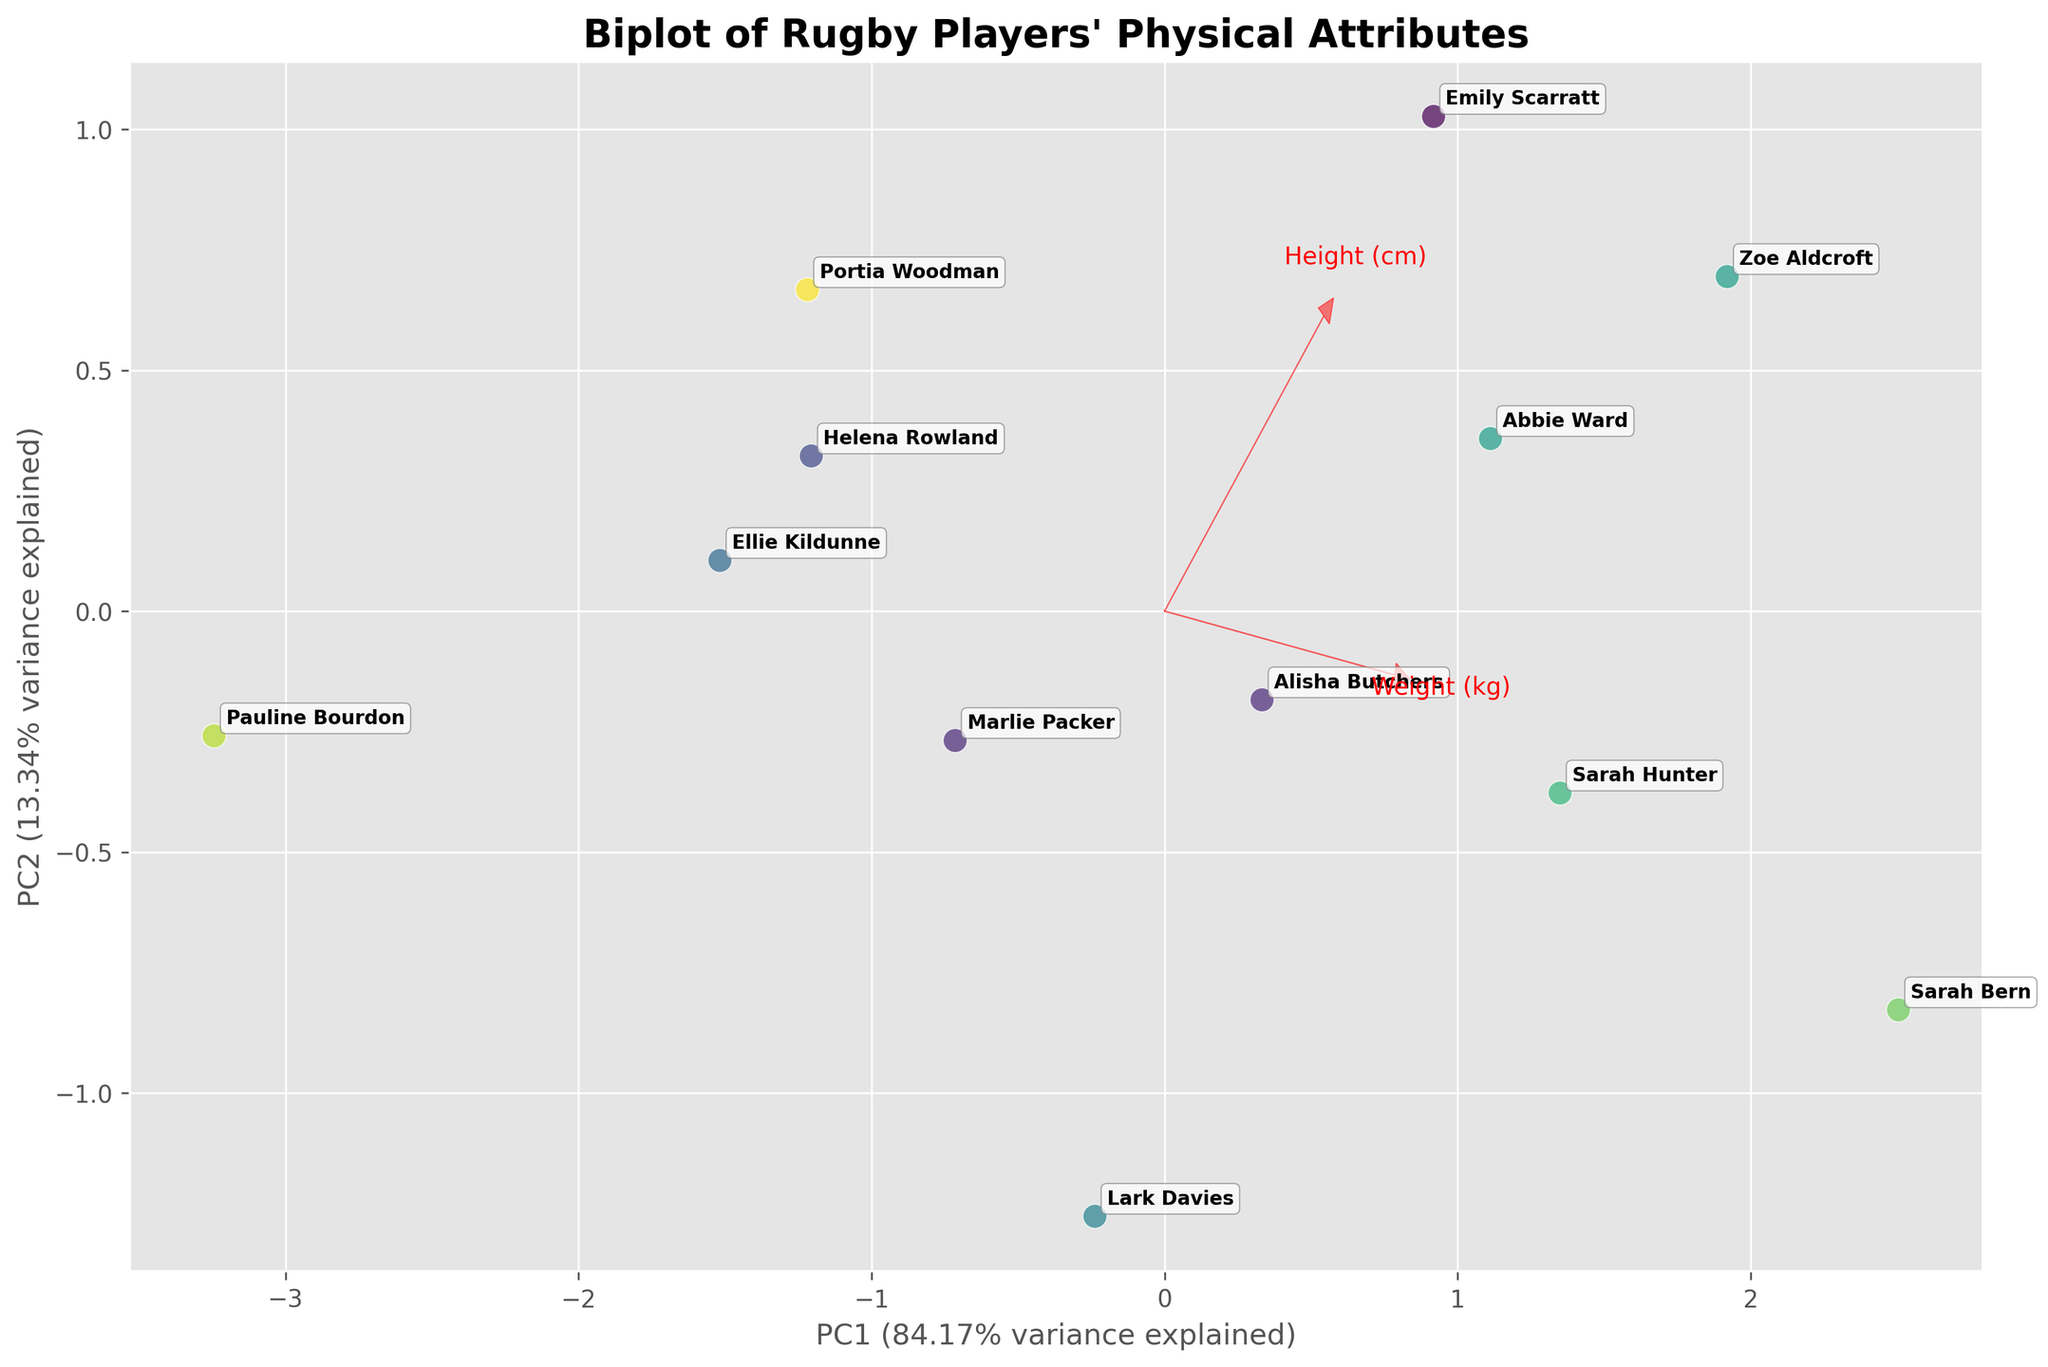How many different positions are represented in the plot? The legend in the top-right corner lists the different positions, which we can count directly.
Answer: 9 Which direction is the feature vector for 'Weight (kg)' pointing? By looking at the red arrows (feature vectors), we see that the 'Weight (kg)' vector points toward the top right.
Answer: Top-right Which player is the closest to the center of the plot? The center of the plot is at (0,0). The player whose data point is closest to this point appears to be Lark Davies.
Answer: Lark Davies Which position tends to have the highest 'Weight (kg)' based on the biplot? The 'Weight (kg)' vector points towards the top right. Players like Sarah Bern and Zoe Aldcroft, whose points are in that direction, are Prop and Lock, respectively.
Answer: Prop, Lock Is there any observable relationship between 'Height (cm)' and '40m Sprint (s)'? If yes, what is it? The vectors for 'Height (cm)' and '40m Sprint (s)' point in nearly opposite directions. This suggests an inverse relationship: taller players tend to have slower sprint times.
Answer: Inverse relationship Which player is the fastest based on the plot? The player nearest to the tip of the '40m Sprint (s)' vector. Pauline Bourdon is closest to this vector, indicating the fastest sprint time.
Answer: Pauline Bourdon Which physical attribute contributes the most to the first principal component (PC1)? The length and direction of the feature vectors indicate contribution. The 'Weight (kg)' vector is the longest along PC1.
Answer: Weight (kg) How much variance is explained by the first principal component? The x-axis label indicates the amount of variance explained by PC1, which is shown as a percentage on the plot.
Answer: ~52% Which two players are most similar based on their physical attributes in the biplot? The proximity of data points indicates similarity. Emily Scarratt and Sarah Bern appear to be the closest to each other.
Answer: Emily Scarratt and Sarah Bern 